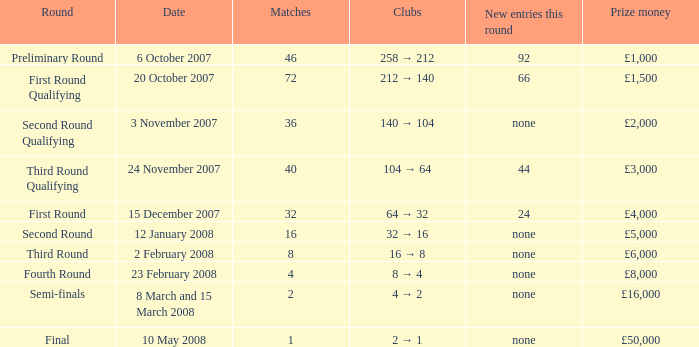I'm looking to parse the entire table for insights. Could you assist me with that? {'header': ['Round', 'Date', 'Matches', 'Clubs', 'New entries this round', 'Prize money'], 'rows': [['Preliminary Round', '6 October 2007', '46', '258 → 212', '92', '£1,000'], ['First Round Qualifying', '20 October 2007', '72', '212 → 140', '66', '£1,500'], ['Second Round Qualifying', '3 November 2007', '36', '140 → 104', 'none', '£2,000'], ['Third Round Qualifying', '24 November 2007', '40', '104 → 64', '44', '£3,000'], ['First Round', '15 December 2007', '32', '64 → 32', '24', '£4,000'], ['Second Round', '12 January 2008', '16', '32 → 16', 'none', '£5,000'], ['Third Round', '2 February 2008', '8', '16 → 8', 'none', '£6,000'], ['Fourth Round', '23 February 2008', '4', '8 → 4', 'none', '£8,000'], ['Semi-finals', '8 March and 15 March 2008', '2', '4 → 2', 'none', '£16,000'], ['Final', '10 May 2008', '1', '2 → 1', 'none', '£50,000']]} What is the mean for games that have a reward sum of £3,000? 40.0. 